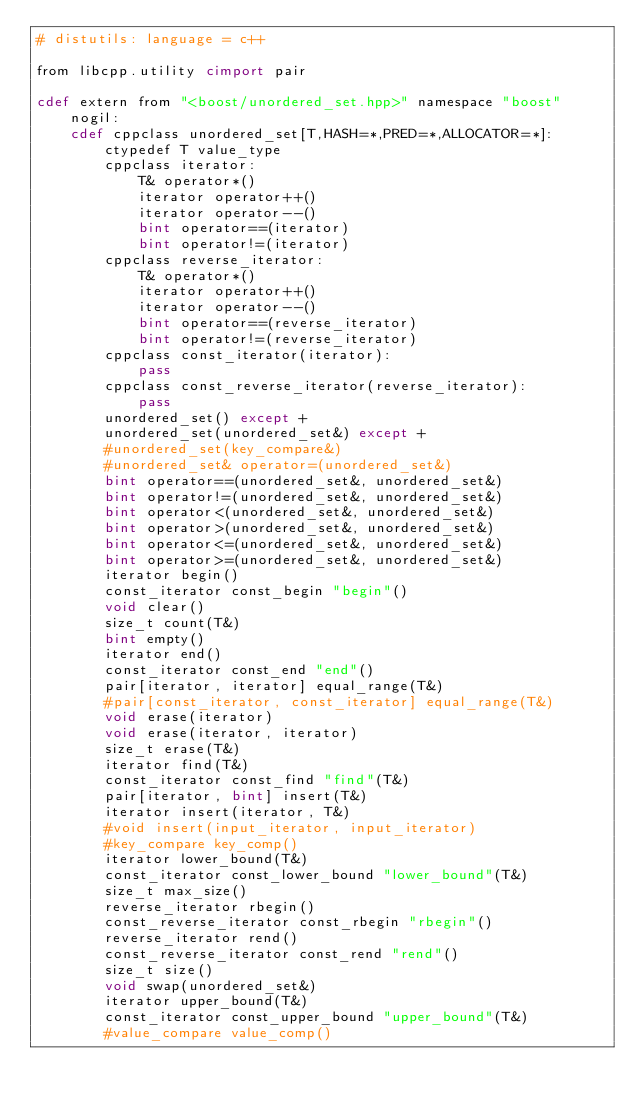<code> <loc_0><loc_0><loc_500><loc_500><_Cython_># distutils: language = c++

from libcpp.utility cimport pair

cdef extern from "<boost/unordered_set.hpp>" namespace "boost" nogil:
    cdef cppclass unordered_set[T,HASH=*,PRED=*,ALLOCATOR=*]:
        ctypedef T value_type
        cppclass iterator:
            T& operator*()
            iterator operator++()
            iterator operator--()
            bint operator==(iterator)
            bint operator!=(iterator)
        cppclass reverse_iterator:
            T& operator*()
            iterator operator++()
            iterator operator--()
            bint operator==(reverse_iterator)
            bint operator!=(reverse_iterator)
        cppclass const_iterator(iterator):
            pass
        cppclass const_reverse_iterator(reverse_iterator):
            pass
        unordered_set() except +
        unordered_set(unordered_set&) except +
        #unordered_set(key_compare&)
        #unordered_set& operator=(unordered_set&)
        bint operator==(unordered_set&, unordered_set&)
        bint operator!=(unordered_set&, unordered_set&)
        bint operator<(unordered_set&, unordered_set&)
        bint operator>(unordered_set&, unordered_set&)
        bint operator<=(unordered_set&, unordered_set&)
        bint operator>=(unordered_set&, unordered_set&)
        iterator begin()
        const_iterator const_begin "begin"()
        void clear()
        size_t count(T&)
        bint empty()
        iterator end()
        const_iterator const_end "end"()
        pair[iterator, iterator] equal_range(T&)
        #pair[const_iterator, const_iterator] equal_range(T&)
        void erase(iterator)
        void erase(iterator, iterator)
        size_t erase(T&)
        iterator find(T&)
        const_iterator const_find "find"(T&)
        pair[iterator, bint] insert(T&)
        iterator insert(iterator, T&)
        #void insert(input_iterator, input_iterator)
        #key_compare key_comp()
        iterator lower_bound(T&)
        const_iterator const_lower_bound "lower_bound"(T&)
        size_t max_size()
        reverse_iterator rbegin()
        const_reverse_iterator const_rbegin "rbegin"()
        reverse_iterator rend()
        const_reverse_iterator const_rend "rend"()
        size_t size()
        void swap(unordered_set&)
        iterator upper_bound(T&)
        const_iterator const_upper_bound "upper_bound"(T&)
        #value_compare value_comp()
</code> 